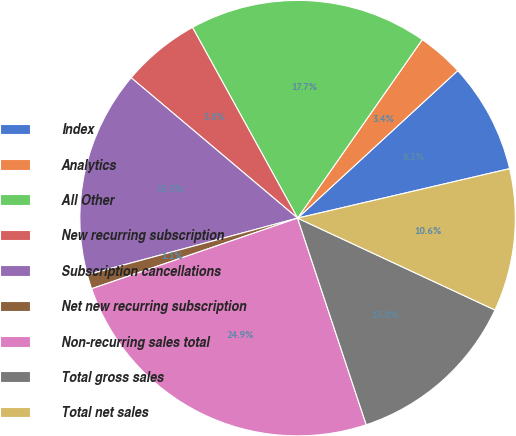Convert chart. <chart><loc_0><loc_0><loc_500><loc_500><pie_chart><fcel>Index<fcel>Analytics<fcel>All Other<fcel>New recurring subscription<fcel>Subscription cancellations<fcel>Net new recurring subscription<fcel>Non-recurring sales total<fcel>Total gross sales<fcel>Total net sales<nl><fcel>8.2%<fcel>3.45%<fcel>17.72%<fcel>5.83%<fcel>15.34%<fcel>1.07%<fcel>24.85%<fcel>12.96%<fcel>10.58%<nl></chart> 